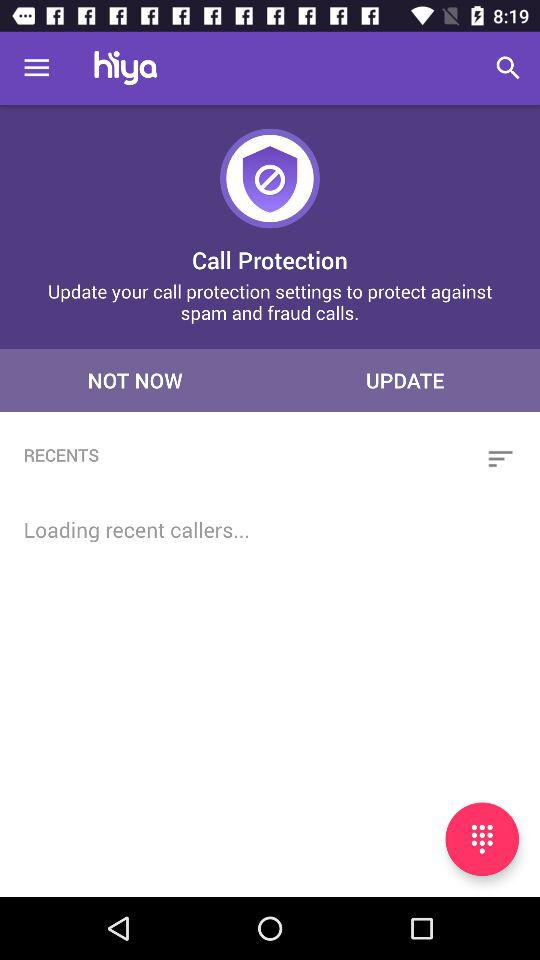Who are the recent callers?
When the provided information is insufficient, respond with <no answer>. <no answer> 